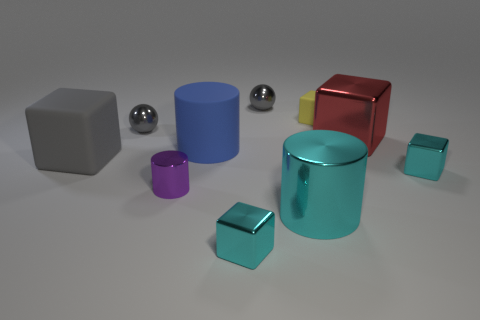Subtract all cyan blocks. How many blocks are left? 3 Subtract all big red shiny cubes. How many cubes are left? 4 Subtract all green cubes. Subtract all green cylinders. How many cubes are left? 5 Subtract all cylinders. How many objects are left? 7 Subtract 0 blue blocks. How many objects are left? 10 Subtract all tiny gray objects. Subtract all small yellow matte things. How many objects are left? 7 Add 5 tiny balls. How many tiny balls are left? 7 Add 9 large gray cylinders. How many large gray cylinders exist? 9 